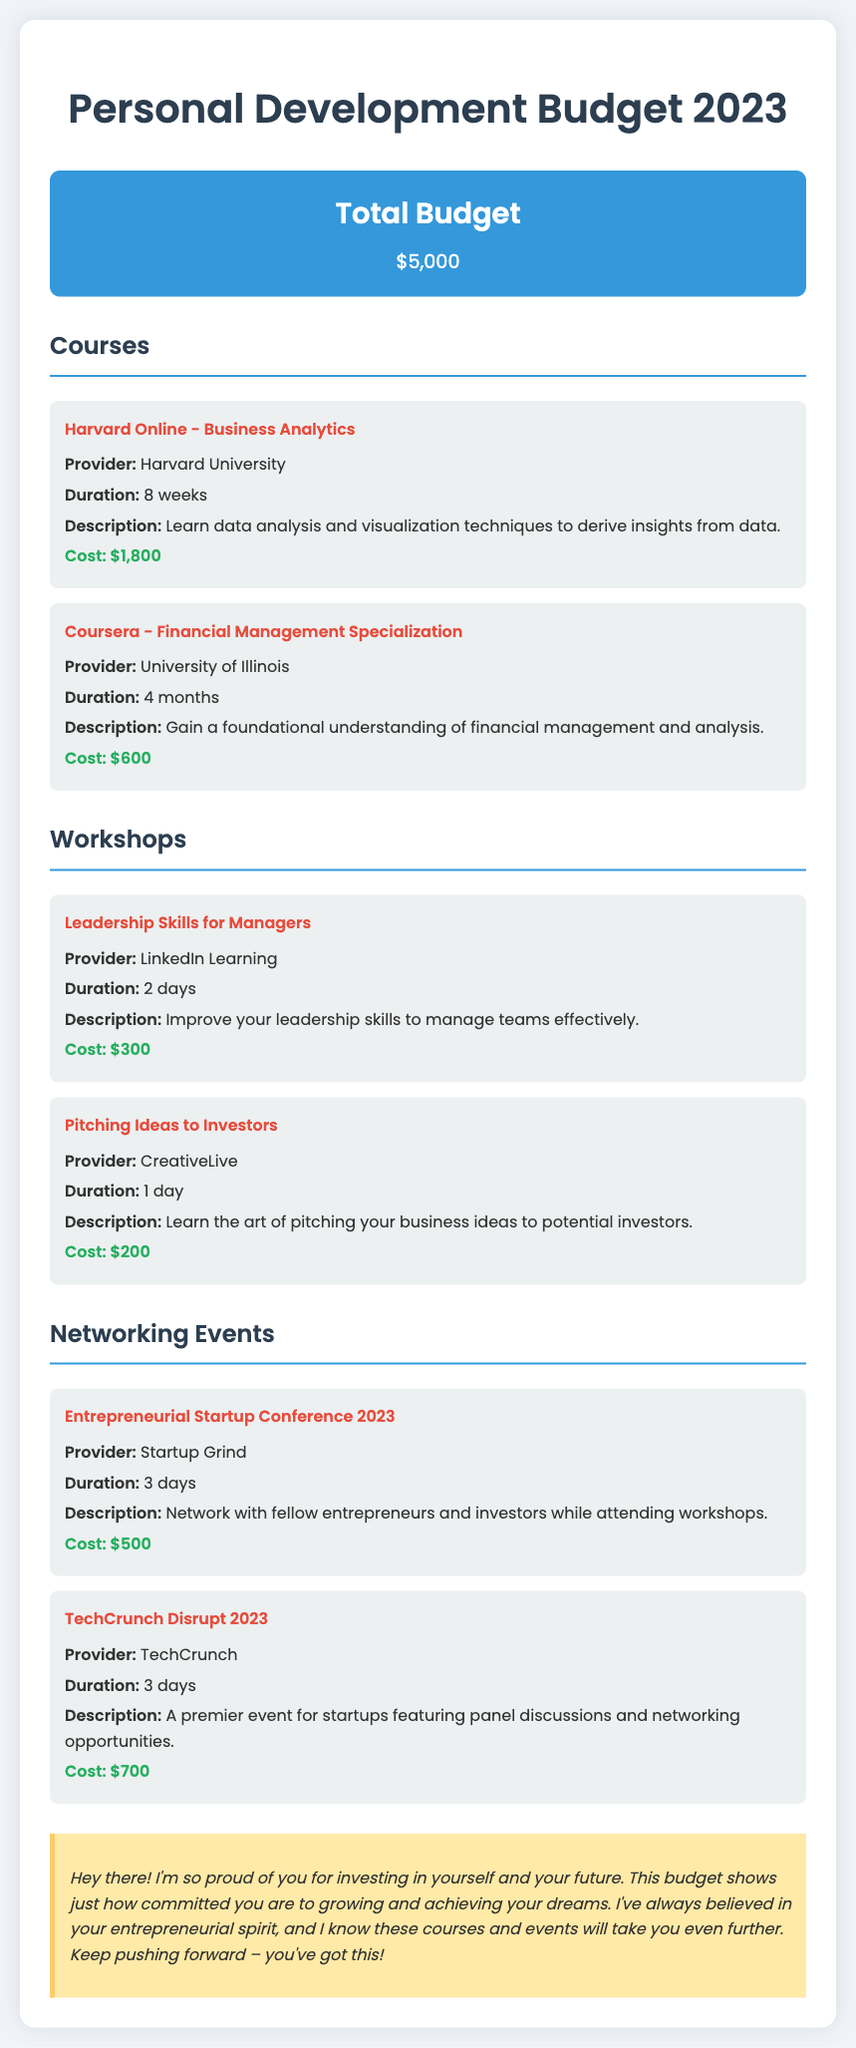What is the total budget? The total budget is stated at the beginning of the document, which is $5,000.
Answer: $5,000 How much does the Harvard Online course cost? The cost of the Harvard Online course is specified in the document under the Courses section.
Answer: $1,800 What is the duration of the TechCrunch Disrupt 2023 event? The duration is mentioned in the description of the TechCrunch Disrupt 2023 event.
Answer: 3 days Which course is provided by the University of Illinois? The course title along with the provider is listed under the Courses section in the document.
Answer: Financial Management Specialization What is the total cost of the workshops mentioned? To find the total, add the costs of both workshops listed in the document: $300 + $200.
Answer: $500 What main skill is targeted by the Leadership Skills for Managers workshop? The document specifies that the workshop aims to improve leadership skills.
Answer: Leadership skills Who is the provider of the Entrepreneurial Startup Conference 2023? The provider is listed in the description of the event in the Networking Events section.
Answer: Startup Grind How many workshops are detailed in the document? By counting the distinct workshops listed in the document, there are two workshops mentioned.
Answer: 2 What is emphasized in the friend note? The friend note highlights the importance of investing in oneself and shows support for entrepreneurial ambitions.
Answer: Support for investing in oneself 